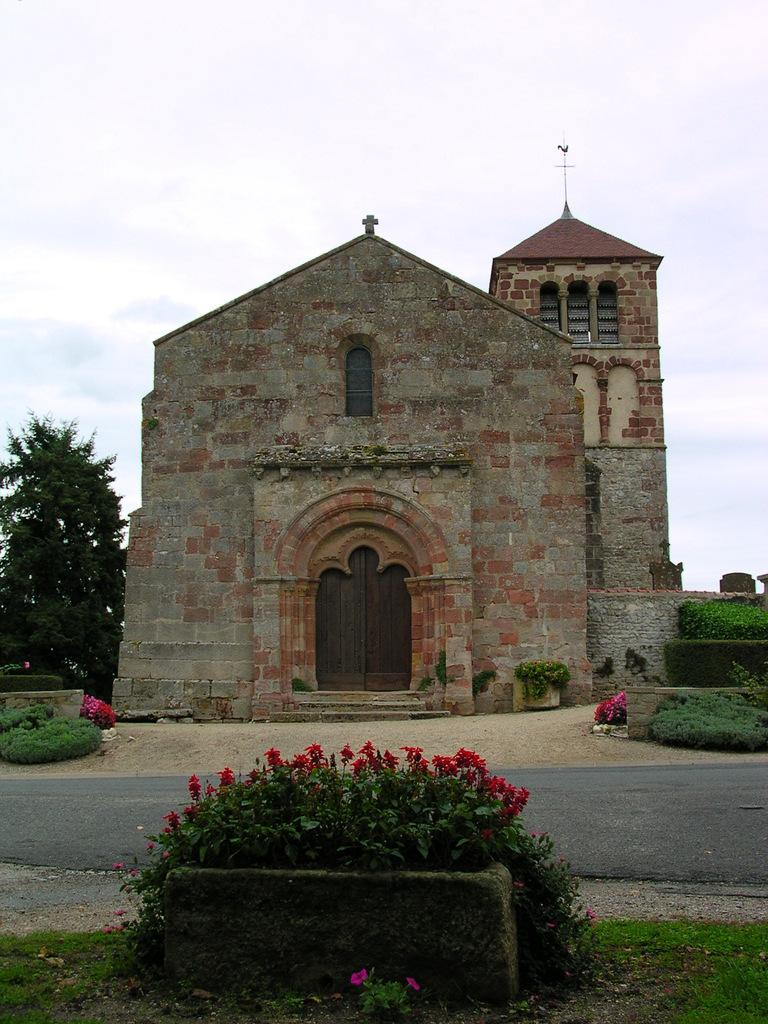What types of plants can be seen in the foreground of the image? There are flowering plants and trees in the foreground of the image. What type of vegetation is present in the foreground of the image? There is grass in the foreground of the image. What structure can be seen in the foreground of the image? There is a fence in the foreground of the image. What type of structures are visible in the foreground of the image? There are buildings in the foreground of the image. What part of the natural environment is visible in the image? The sky is visible at the top of the image. Can you determine the time of day the image was taken? The image was likely taken during the day, as the sky is visible and there is no indication of darkness. What type of friction can be seen between the insect and the bulb in the image? There is no insect or bulb present in the image. How does the bulb affect the growth of the plants in the image? There is no bulb present in the image, so its effect on the plants cannot be determined. 